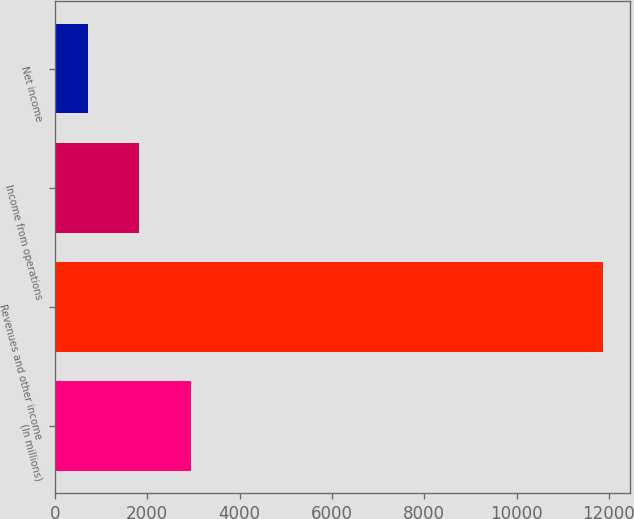<chart> <loc_0><loc_0><loc_500><loc_500><bar_chart><fcel>(In millions)<fcel>Revenues and other income<fcel>Income from operations<fcel>Net income<nl><fcel>2942.6<fcel>11873<fcel>1826.3<fcel>710<nl></chart> 